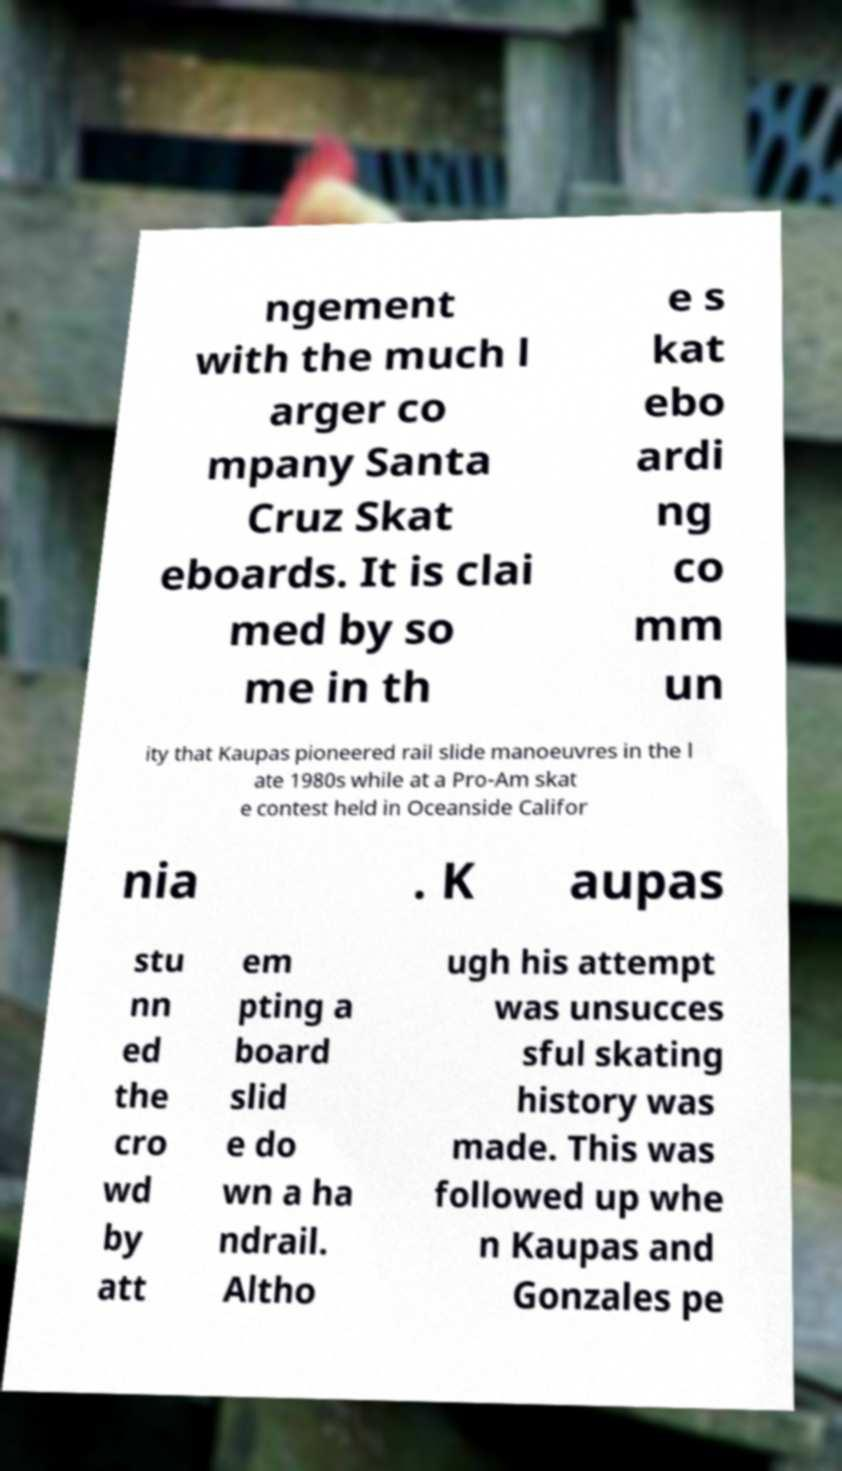Can you read and provide the text displayed in the image?This photo seems to have some interesting text. Can you extract and type it out for me? ngement with the much l arger co mpany Santa Cruz Skat eboards. It is clai med by so me in th e s kat ebo ardi ng co mm un ity that Kaupas pioneered rail slide manoeuvres in the l ate 1980s while at a Pro-Am skat e contest held in Oceanside Califor nia . K aupas stu nn ed the cro wd by att em pting a board slid e do wn a ha ndrail. Altho ugh his attempt was unsucces sful skating history was made. This was followed up whe n Kaupas and Gonzales pe 